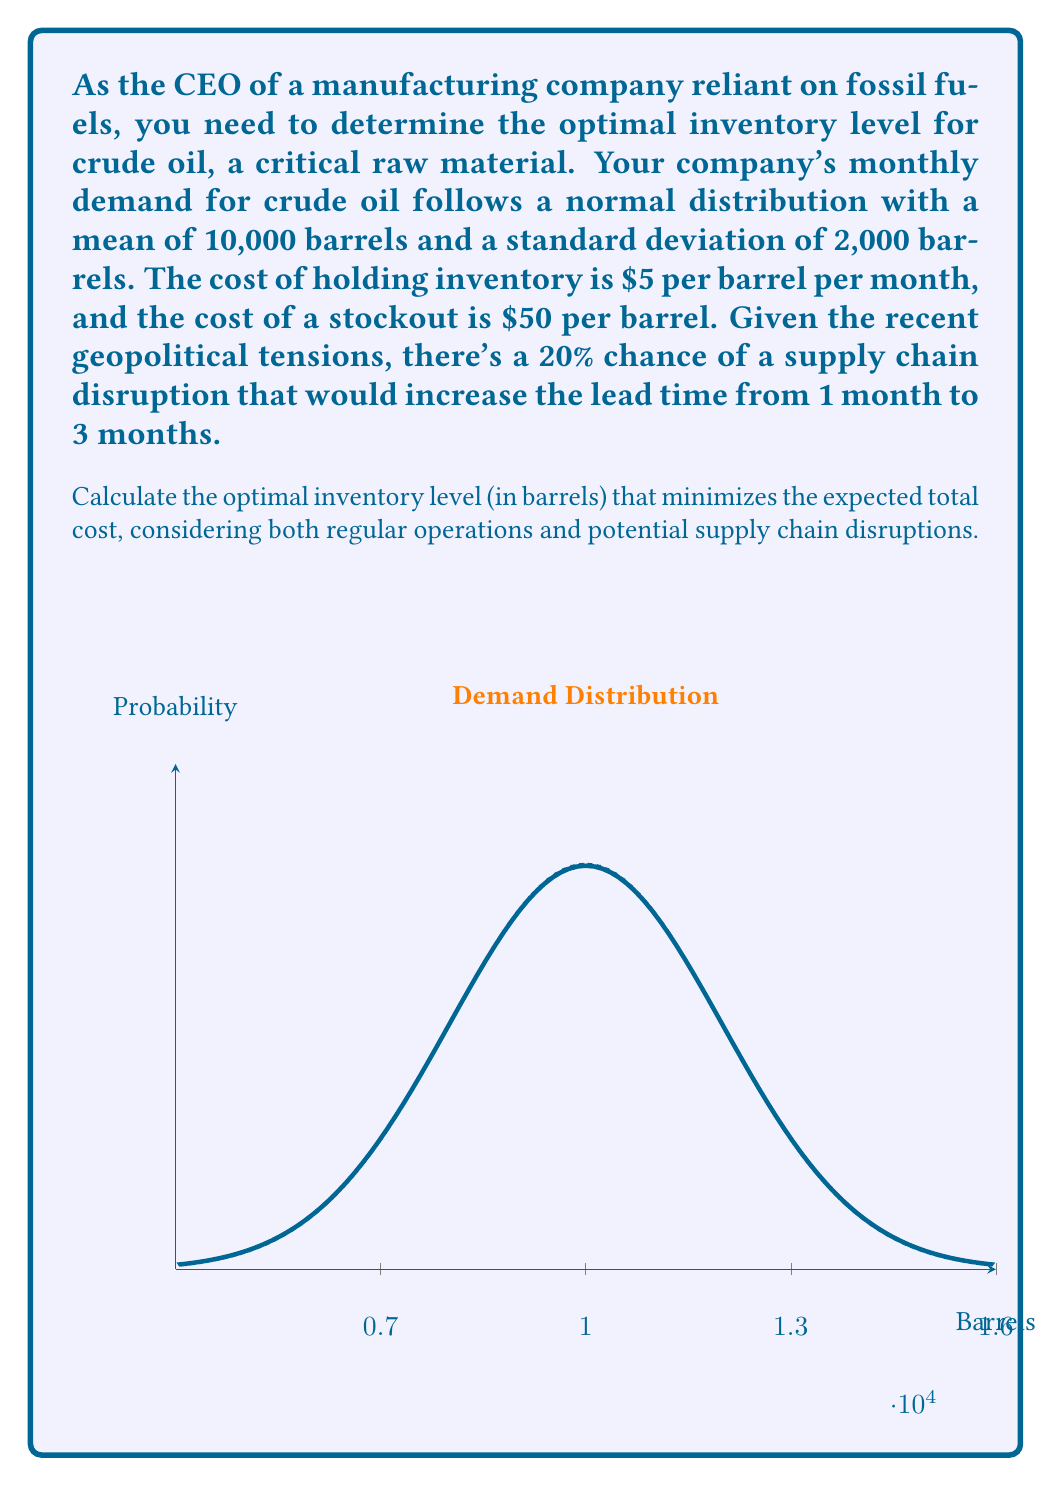Provide a solution to this math problem. Let's approach this problem step-by-step using the newsvendor model and considering the probability of supply chain disruption:

1) First, we need to calculate the critical fractile (CF):
   $CF = \frac{C_u}{C_u + C_o}$
   Where $C_u$ is the cost of understocking and $C_o$ is the cost of overstocking.
   $CF = \frac{50}{50 + 5} = 0.9091$

2) For a normal distribution, we can find the optimal inventory level using the inverse normal distribution function:
   $Q^* = \mu + \sigma \cdot Z_{CF}$
   Where $\mu$ is the mean, $\sigma$ is the standard deviation, and $Z_{CF}$ is the Z-score for the critical fractile.

3) For CF = 0.9091, $Z_{CF} \approx 1.34$ (using a standard normal distribution table)

4) Now, let's consider the two scenarios:
   a) Regular scenario (80% probability):
      $Q^*_{\text{regular}} = 10000 + 2000 \cdot 1.34 = 12680$ barrels

   b) Disruption scenario (20% probability):
      In this case, we need to consider 3 months of demand:
      $\mu_{\text{disruption}} = 3 \cdot 10000 = 30000$
      $\sigma_{\text{disruption}} = \sqrt{3} \cdot 2000 \approx 3464$
      $Q^*_{\text{disruption}} = 30000 + 3464 \cdot 1.34 = 34642$ barrels

5) The optimal inventory level considering both scenarios is the weighted average:
   $Q^*_{\text{optimal}} = 0.8 \cdot Q^*_{\text{regular}} + 0.2 \cdot Q^*_{\text{disruption}}$
   $Q^*_{\text{optimal}} = 0.8 \cdot 12680 + 0.2 \cdot 34642 = 17072.4$ barrels

6) Rounding to the nearest whole number of barrels:
   $Q^*_{\text{optimal}} = 17072$ barrels
Answer: 17072 barrels 